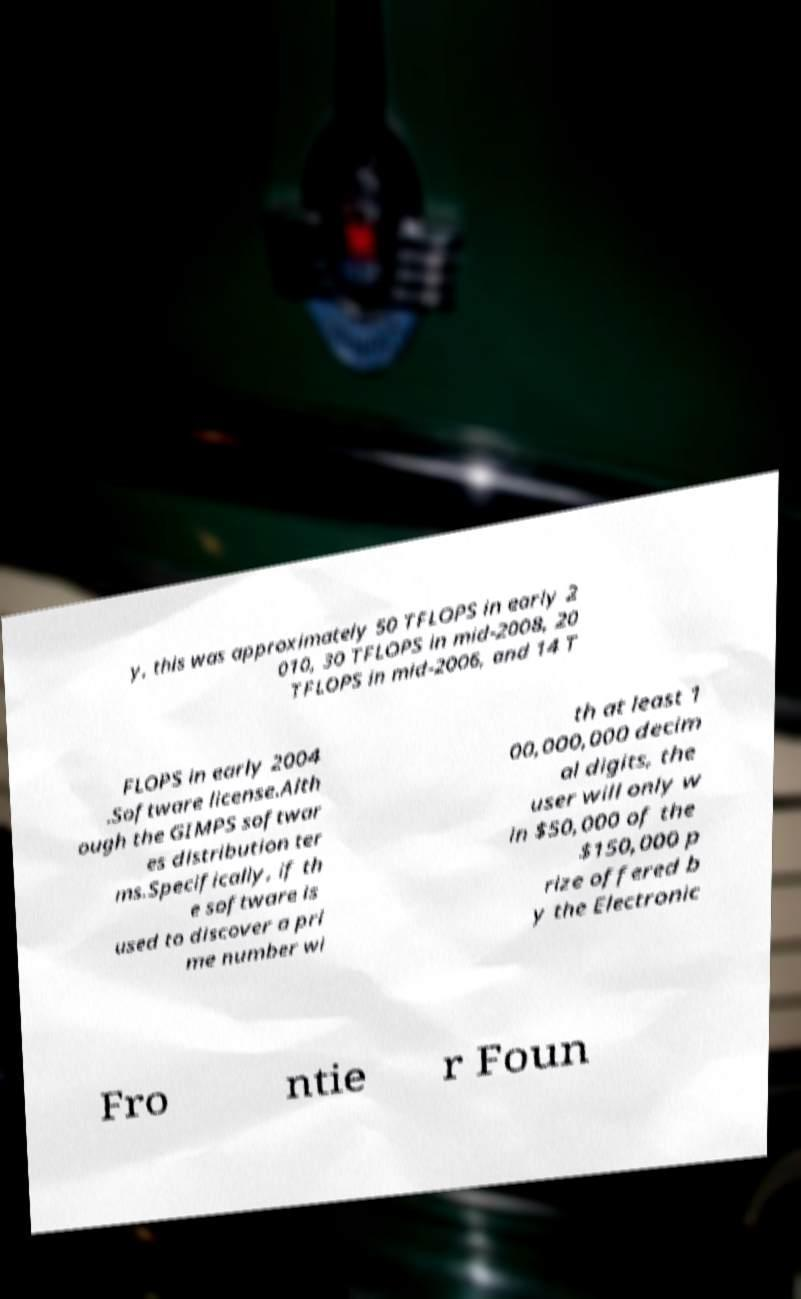What messages or text are displayed in this image? I need them in a readable, typed format. y, this was approximately 50 TFLOPS in early 2 010, 30 TFLOPS in mid-2008, 20 TFLOPS in mid-2006, and 14 T FLOPS in early 2004 .Software license.Alth ough the GIMPS softwar es distribution ter ms.Specifically, if th e software is used to discover a pri me number wi th at least 1 00,000,000 decim al digits, the user will only w in $50,000 of the $150,000 p rize offered b y the Electronic Fro ntie r Foun 